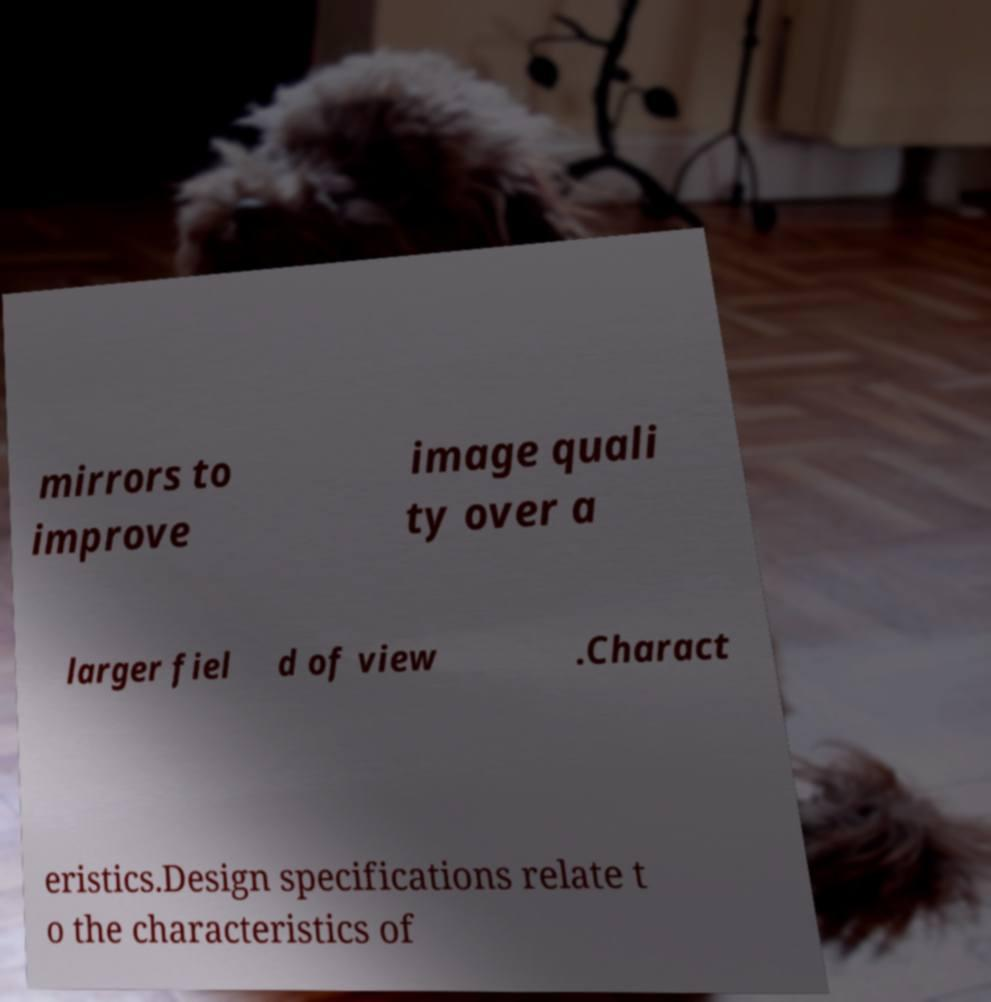Could you assist in decoding the text presented in this image and type it out clearly? mirrors to improve image quali ty over a larger fiel d of view .Charact eristics.Design specifications relate t o the characteristics of 